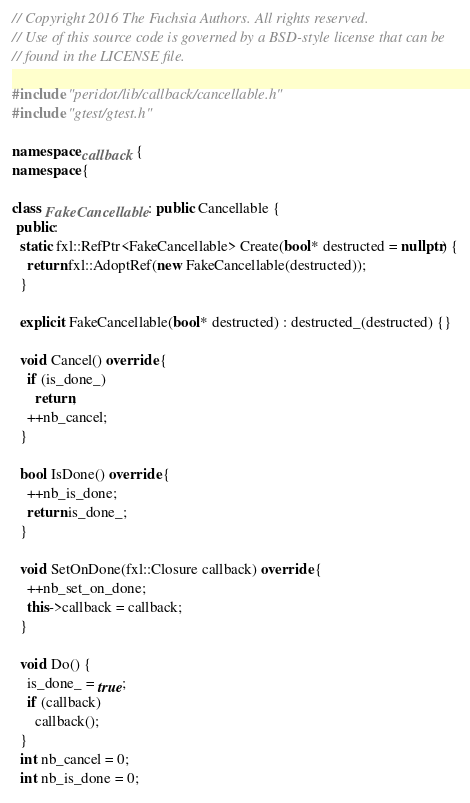<code> <loc_0><loc_0><loc_500><loc_500><_C++_>// Copyright 2016 The Fuchsia Authors. All rights reserved.
// Use of this source code is governed by a BSD-style license that can be
// found in the LICENSE file.

#include "peridot/lib/callback/cancellable.h"
#include "gtest/gtest.h"

namespace callback {
namespace {

class FakeCancellable : public Cancellable {
 public:
  static fxl::RefPtr<FakeCancellable> Create(bool* destructed = nullptr) {
    return fxl::AdoptRef(new FakeCancellable(destructed));
  }

  explicit FakeCancellable(bool* destructed) : destructed_(destructed) {}

  void Cancel() override {
    if (is_done_)
      return;
    ++nb_cancel;
  }

  bool IsDone() override {
    ++nb_is_done;
    return is_done_;
  }

  void SetOnDone(fxl::Closure callback) override {
    ++nb_set_on_done;
    this->callback = callback;
  }

  void Do() {
    is_done_ = true;
    if (callback)
      callback();
  }
  int nb_cancel = 0;
  int nb_is_done = 0;</code> 